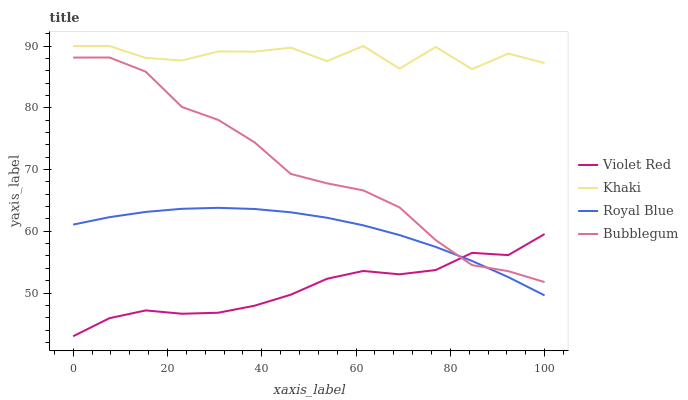Does Violet Red have the minimum area under the curve?
Answer yes or no. Yes. Does Khaki have the maximum area under the curve?
Answer yes or no. Yes. Does Khaki have the minimum area under the curve?
Answer yes or no. No. Does Violet Red have the maximum area under the curve?
Answer yes or no. No. Is Royal Blue the smoothest?
Answer yes or no. Yes. Is Khaki the roughest?
Answer yes or no. Yes. Is Violet Red the smoothest?
Answer yes or no. No. Is Violet Red the roughest?
Answer yes or no. No. Does Violet Red have the lowest value?
Answer yes or no. Yes. Does Khaki have the lowest value?
Answer yes or no. No. Does Khaki have the highest value?
Answer yes or no. Yes. Does Violet Red have the highest value?
Answer yes or no. No. Is Bubblegum less than Khaki?
Answer yes or no. Yes. Is Khaki greater than Bubblegum?
Answer yes or no. Yes. Does Bubblegum intersect Royal Blue?
Answer yes or no. Yes. Is Bubblegum less than Royal Blue?
Answer yes or no. No. Is Bubblegum greater than Royal Blue?
Answer yes or no. No. Does Bubblegum intersect Khaki?
Answer yes or no. No. 